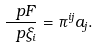<formula> <loc_0><loc_0><loc_500><loc_500>\frac { \ p F } { \ p \xi _ { i } } = \pi ^ { i j } a _ { j } .</formula> 